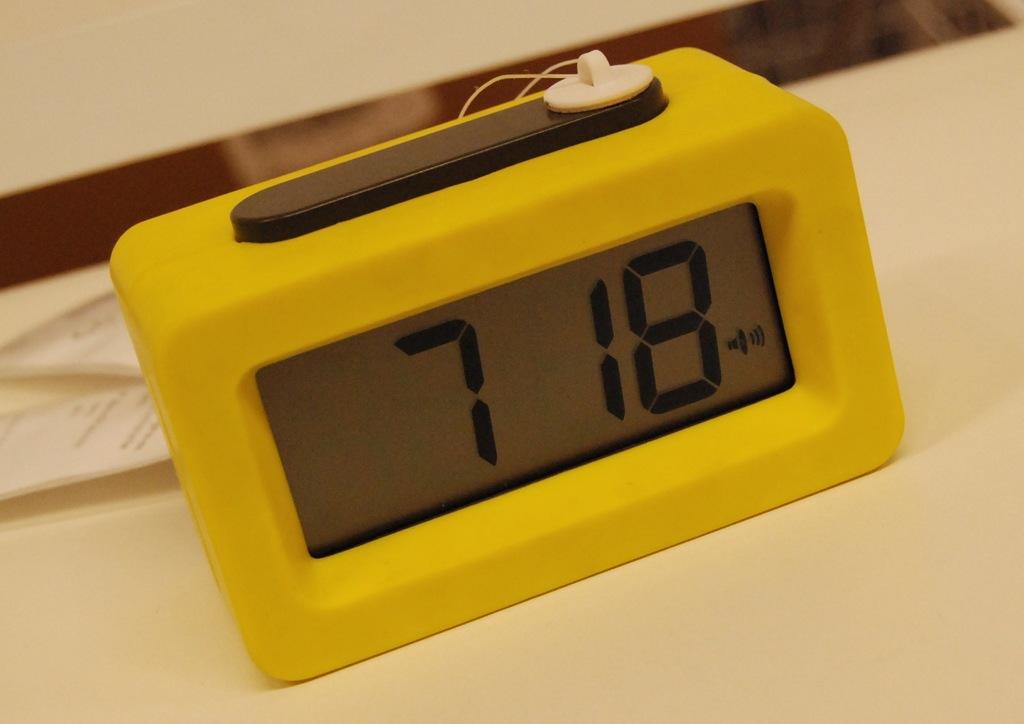What time is it?
Offer a very short reply. 7:18. 